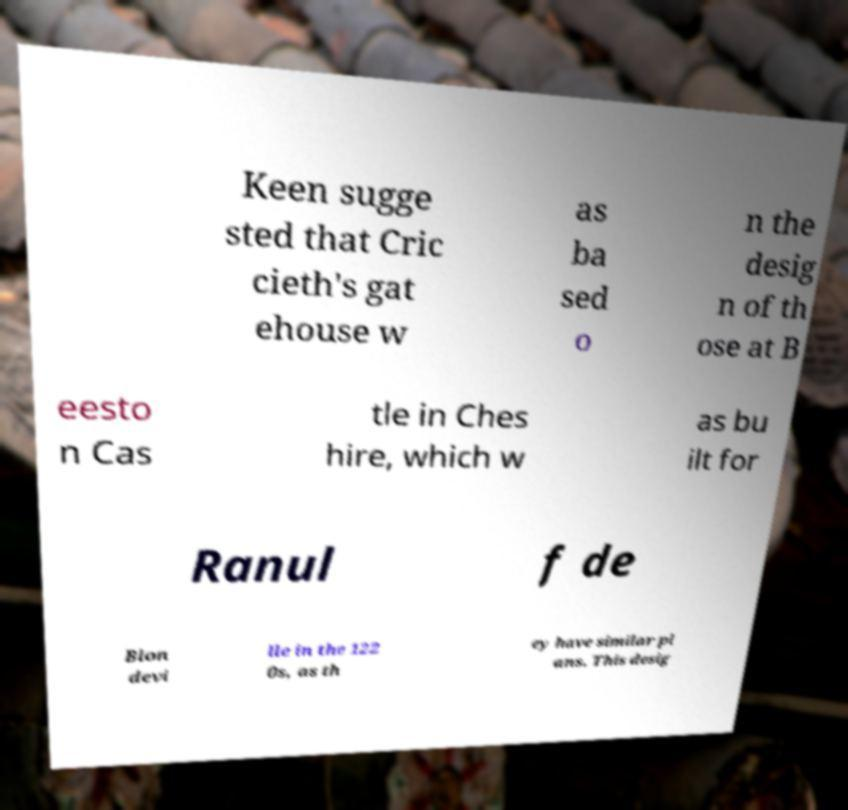Please identify and transcribe the text found in this image. Keen sugge sted that Cric cieth's gat ehouse w as ba sed o n the desig n of th ose at B eesto n Cas tle in Ches hire, which w as bu ilt for Ranul f de Blon devi lle in the 122 0s, as th ey have similar pl ans. This desig 